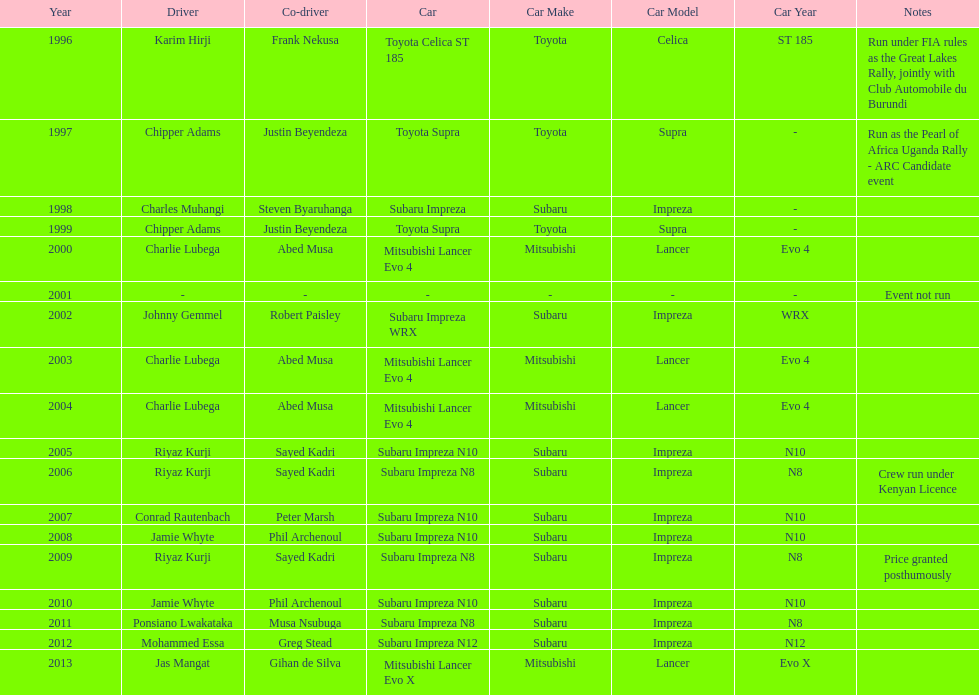Would you mind parsing the complete table? {'header': ['Year', 'Driver', 'Co-driver', 'Car', 'Car Make', 'Car Model', 'Car Year', 'Notes'], 'rows': [['1996', 'Karim Hirji', 'Frank Nekusa', 'Toyota Celica ST 185', 'Toyota', 'Celica', 'ST 185', 'Run under FIA rules as the Great Lakes Rally, jointly with Club Automobile du Burundi'], ['1997', 'Chipper Adams', 'Justin Beyendeza', 'Toyota Supra', 'Toyota', 'Supra', '-', 'Run as the Pearl of Africa Uganda Rally - ARC Candidate event'], ['1998', 'Charles Muhangi', 'Steven Byaruhanga', 'Subaru Impreza', 'Subaru', 'Impreza', '-', ''], ['1999', 'Chipper Adams', 'Justin Beyendeza', 'Toyota Supra', 'Toyota', 'Supra', '-', ''], ['2000', 'Charlie Lubega', 'Abed Musa', 'Mitsubishi Lancer Evo 4', 'Mitsubishi', 'Lancer', 'Evo 4', ''], ['2001', '-', '-', '-', '-', '-', '-', 'Event not run'], ['2002', 'Johnny Gemmel', 'Robert Paisley', 'Subaru Impreza WRX', 'Subaru', 'Impreza', 'WRX', ''], ['2003', 'Charlie Lubega', 'Abed Musa', 'Mitsubishi Lancer Evo 4', 'Mitsubishi', 'Lancer', 'Evo 4', ''], ['2004', 'Charlie Lubega', 'Abed Musa', 'Mitsubishi Lancer Evo 4', 'Mitsubishi', 'Lancer', 'Evo 4', ''], ['2005', 'Riyaz Kurji', 'Sayed Kadri', 'Subaru Impreza N10', 'Subaru', 'Impreza', 'N10', ''], ['2006', 'Riyaz Kurji', 'Sayed Kadri', 'Subaru Impreza N8', 'Subaru', 'Impreza', 'N8', 'Crew run under Kenyan Licence'], ['2007', 'Conrad Rautenbach', 'Peter Marsh', 'Subaru Impreza N10', 'Subaru', 'Impreza', 'N10', ''], ['2008', 'Jamie Whyte', 'Phil Archenoul', 'Subaru Impreza N10', 'Subaru', 'Impreza', 'N10', ''], ['2009', 'Riyaz Kurji', 'Sayed Kadri', 'Subaru Impreza N8', 'Subaru', 'Impreza', 'N8', 'Price granted posthumously'], ['2010', 'Jamie Whyte', 'Phil Archenoul', 'Subaru Impreza N10', 'Subaru', 'Impreza', 'N10', ''], ['2011', 'Ponsiano Lwakataka', 'Musa Nsubuga', 'Subaru Impreza N8', 'Subaru', 'Impreza', 'N8', ''], ['2012', 'Mohammed Essa', 'Greg Stead', 'Subaru Impreza N12', 'Subaru', 'Impreza', 'N12', ''], ['2013', 'Jas Mangat', 'Gihan de Silva', 'Mitsubishi Lancer Evo X', 'Mitsubishi', 'Lancer', 'Evo X', '']]} What is the total number of times that the winning driver was driving a toyota supra? 2. 